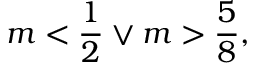<formula> <loc_0><loc_0><loc_500><loc_500>m < \frac { 1 } { 2 } \lor m > \frac { 5 } { 8 } ,</formula> 